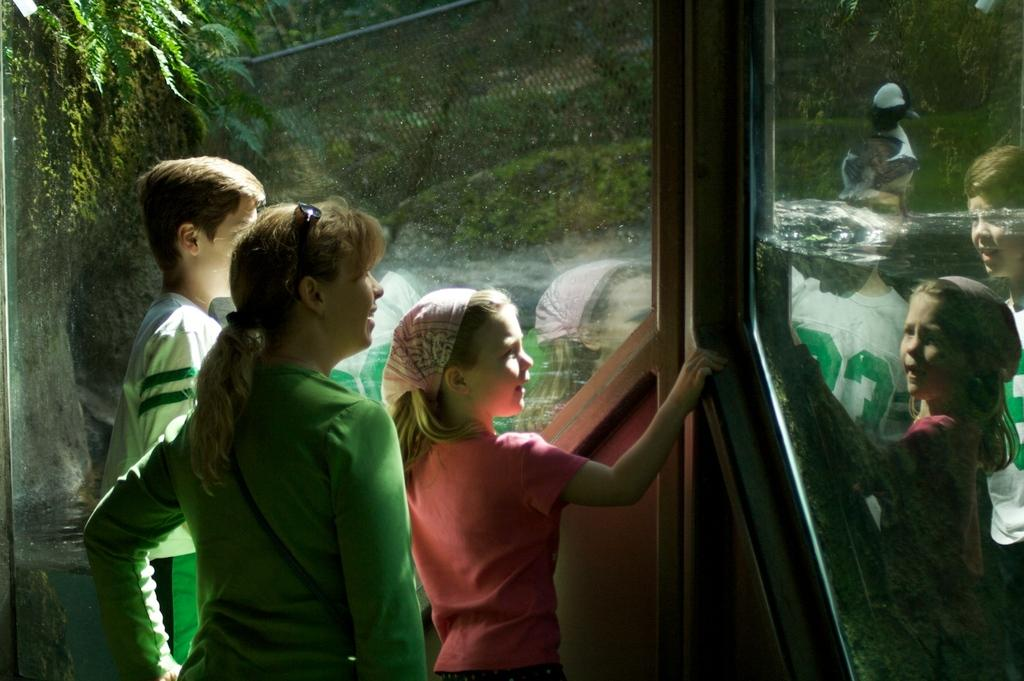What are the people doing in front of the glass door? The people are standing in front of a glass door. What effect does the glass door have on the people? The glass door provides a reflection of the people. What can be seen through the glass door? The view through the glass door includes trees, water, and a bird. Can you see any bricks in the image? There is no mention of bricks in the image. Does the image prove the existence of unicorns? The image does not mention or depict unicorns, so it cannot prove their existence. 